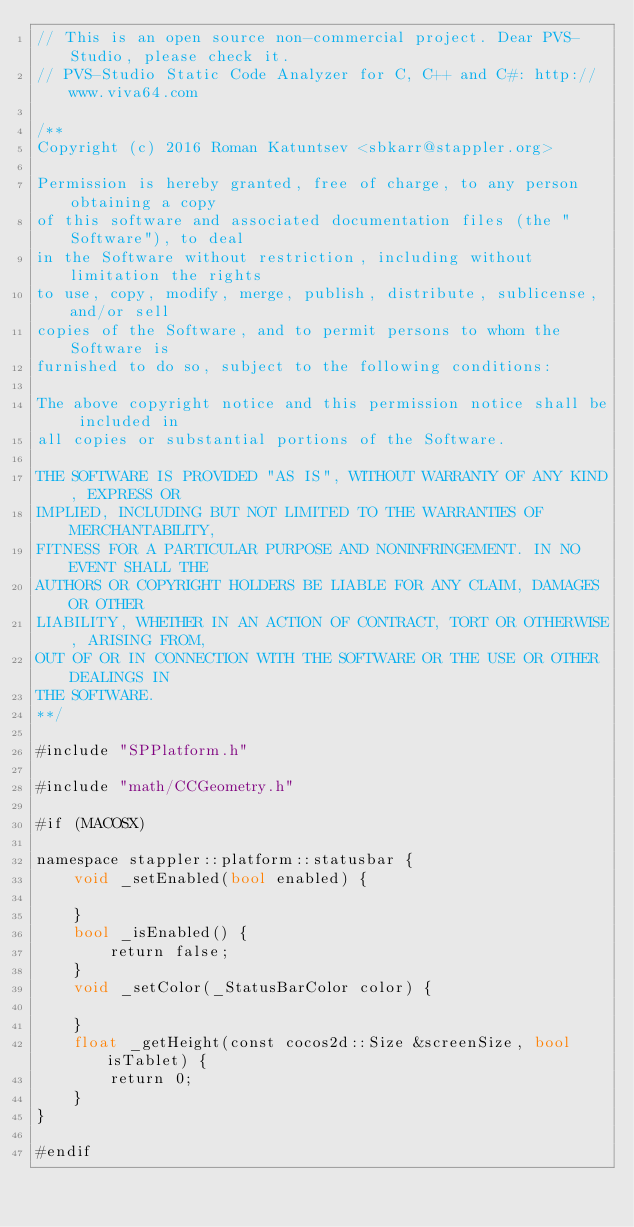<code> <loc_0><loc_0><loc_500><loc_500><_ObjectiveC_>// This is an open source non-commercial project. Dear PVS-Studio, please check it.
// PVS-Studio Static Code Analyzer for C, C++ and C#: http://www.viva64.com

/**
Copyright (c) 2016 Roman Katuntsev <sbkarr@stappler.org>

Permission is hereby granted, free of charge, to any person obtaining a copy
of this software and associated documentation files (the "Software"), to deal
in the Software without restriction, including without limitation the rights
to use, copy, modify, merge, publish, distribute, sublicense, and/or sell
copies of the Software, and to permit persons to whom the Software is
furnished to do so, subject to the following conditions:

The above copyright notice and this permission notice shall be included in
all copies or substantial portions of the Software.

THE SOFTWARE IS PROVIDED "AS IS", WITHOUT WARRANTY OF ANY KIND, EXPRESS OR
IMPLIED, INCLUDING BUT NOT LIMITED TO THE WARRANTIES OF MERCHANTABILITY,
FITNESS FOR A PARTICULAR PURPOSE AND NONINFRINGEMENT. IN NO EVENT SHALL THE
AUTHORS OR COPYRIGHT HOLDERS BE LIABLE FOR ANY CLAIM, DAMAGES OR OTHER
LIABILITY, WHETHER IN AN ACTION OF CONTRACT, TORT OR OTHERWISE, ARISING FROM,
OUT OF OR IN CONNECTION WITH THE SOFTWARE OR THE USE OR OTHER DEALINGS IN
THE SOFTWARE.
**/

#include "SPPlatform.h"

#include "math/CCGeometry.h"

#if (MACOSX)

namespace stappler::platform::statusbar {
	void _setEnabled(bool enabled) {
		
	}
	bool _isEnabled() {
		return false;
	}
	void _setColor(_StatusBarColor color) {
		
	}
	float _getHeight(const cocos2d::Size &screenSize, bool isTablet) {
		return 0;
	}
}

#endif
</code> 